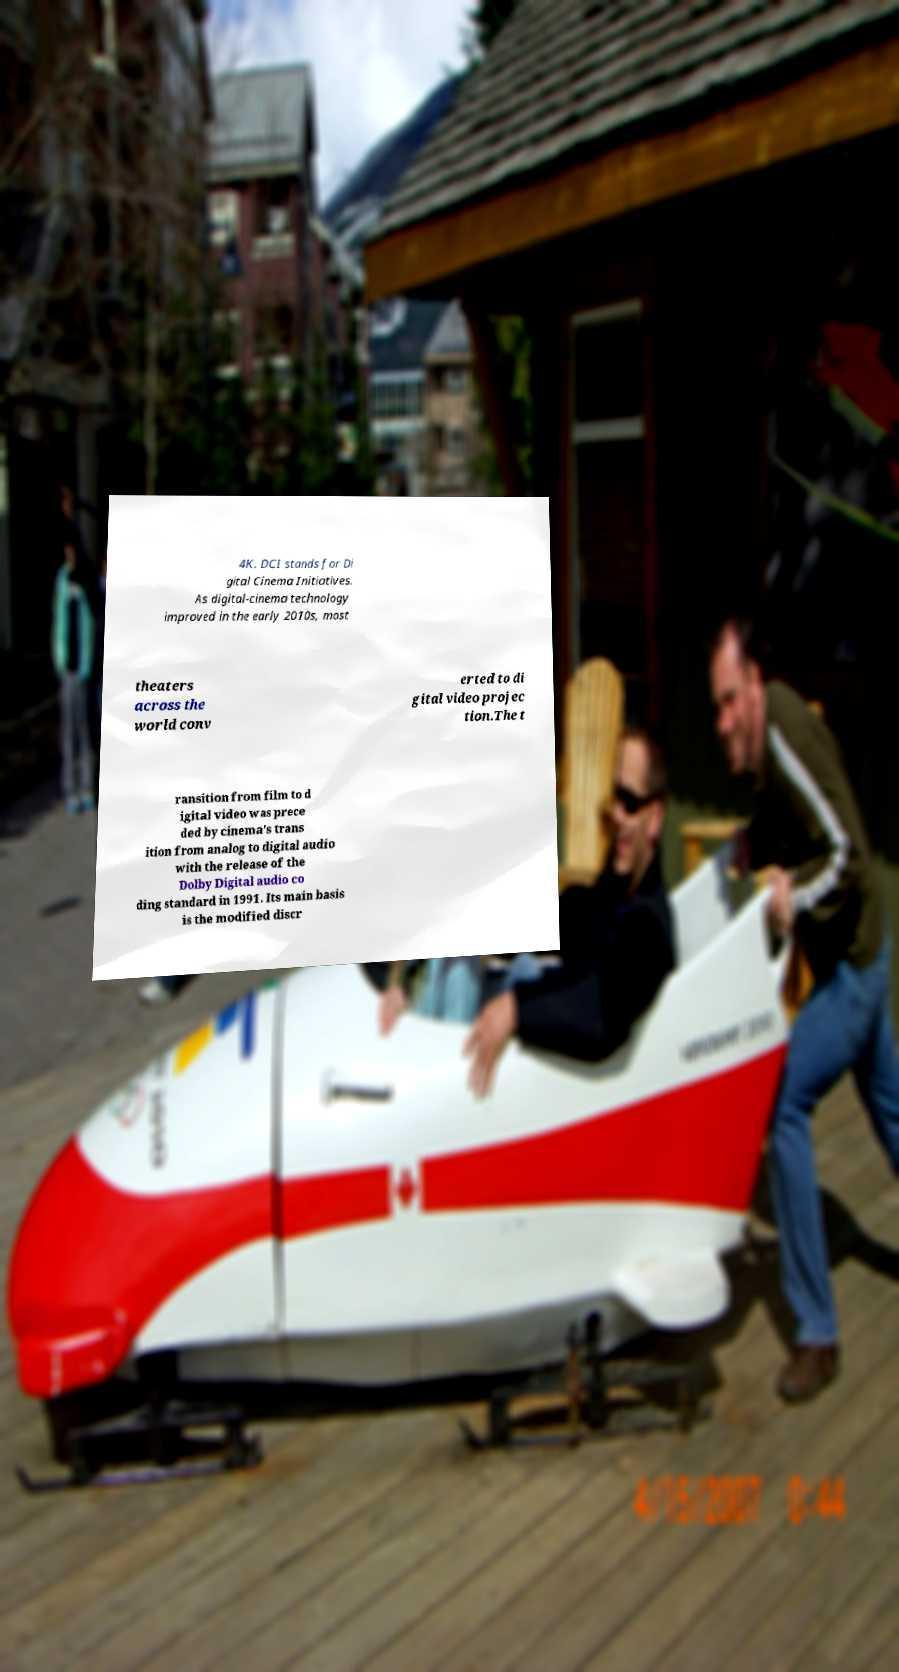For documentation purposes, I need the text within this image transcribed. Could you provide that? 4K. DCI stands for Di gital Cinema Initiatives. As digital-cinema technology improved in the early 2010s, most theaters across the world conv erted to di gital video projec tion.The t ransition from film to d igital video was prece ded by cinema's trans ition from analog to digital audio with the release of the Dolby Digital audio co ding standard in 1991. Its main basis is the modified discr 